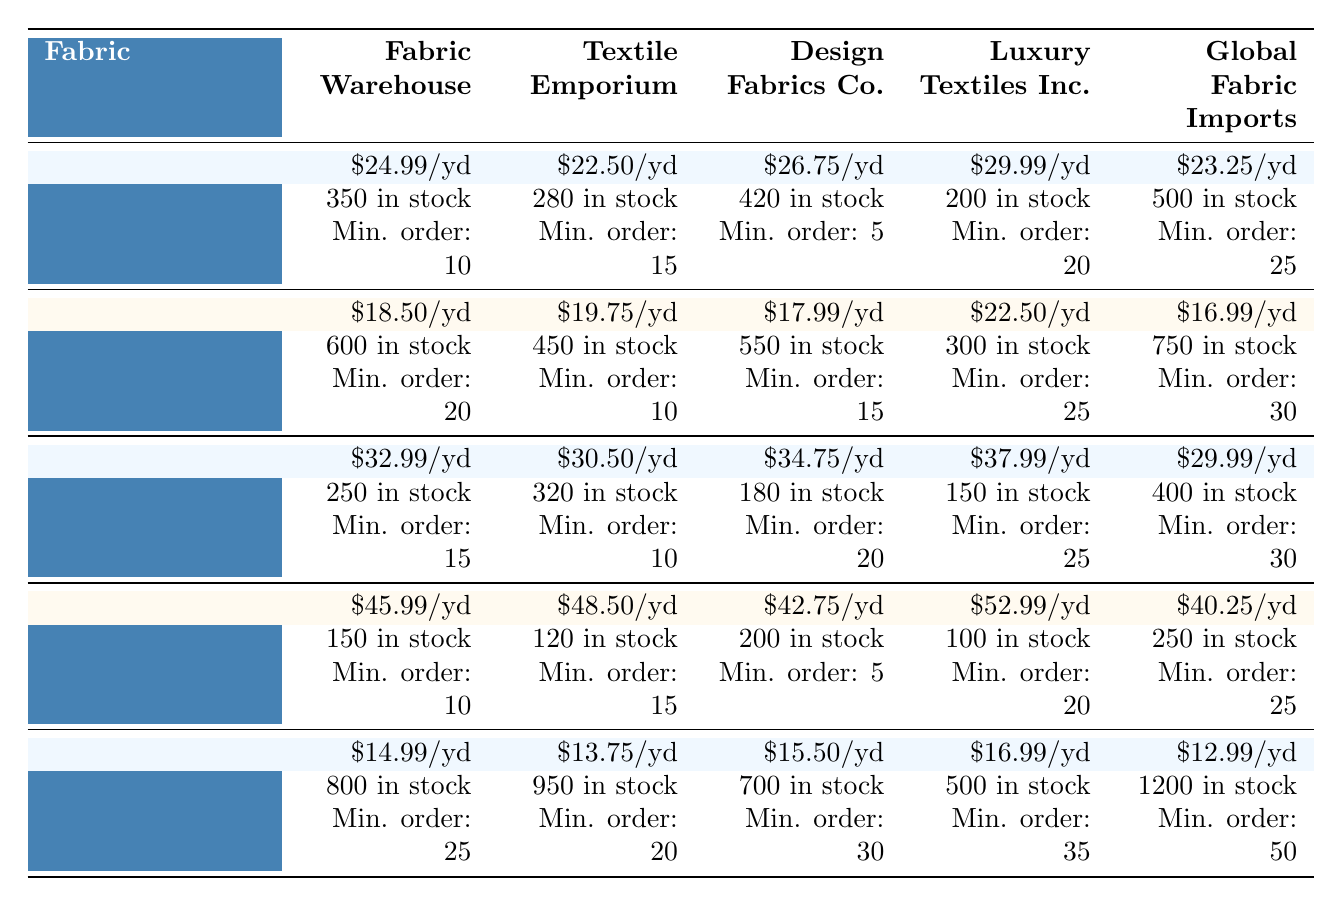What is the price per yard of Velvet from Textile Emporium? The table shows the price per yard of Velvet from Textile Emporium as $22.50.
Answer: $22.50 Which supplier has the highest price for Silk? Looking at the table, Luxury Textiles Inc. has the highest price for Silk at $52.99.
Answer: Luxury Textiles Inc What is the total in-stock quantity of Chenille across all suppliers? The in-stock quantities for Chenille are: Fabric Warehouse - 250, Textile Emporium - 320, Design Fabrics Co. - 180, Luxury Textiles Inc. - 150, and Global Fabric Imports - 400. Adding these amounts gives 250 + 320 + 180 + 150 + 400 = 1300.
Answer: 1300 Which supplier has the lowest minimum order quantity for Linen? The minimum order quantities for Linen are: Fabric Warehouse - 20, Textile Emporium - 10, Design Fabrics Co. - 15, Luxury Textiles Inc. - 25, and Global Fabric Imports - 30. The lowest minimum order quantity is from Textile Emporium at 10 yards.
Answer: 10 Is the stock of Polyester Blend at Global Fabric Imports greater than that of Chenille at Design Fabrics Co.? Polyester Blend at Global Fabric Imports has 1200 in stock, while Chenille at Design Fabrics Co. has 180 in stock. Since 1200 is greater than 180, the answer is yes.
Answer: Yes What is the average price per yard of upholstery fabrics? The upholstery fabrics are Velvet ($24.99), Chenille ($32.99), and Polyester Blend ($14.99). The average is calculated as (24.99 + 32.99 + 14.99) / 3 = 24.32.
Answer: $24.32 Which fabric has the highest stock level and which supplier provides it? From the table, Polyester Blend has the highest stock level at 1200 yards, provided by Global Fabric Imports.
Answer: Polyester Blend, Global Fabric Imports What is the minimum order quantity for Linen from Design Fabrics Co.? The table indicates that the minimum order quantity for Linen from Design Fabrics Co. is 15 yards.
Answer: 15 How does the price per yard of Silk from Global Fabric Imports compare to the lowest priced Silk? The lowest price for Silk is from Design Fabrics Co. at $42.75, while Global Fabric Imports charges $40.25. Since $40.25 is lower, the answer is that Global Fabric Imports has a lower price.
Answer: Lower If I buy 30 yards of Chenille from Textile Emporium, how much will it cost? The price per yard of Chenille from Textile Emporium is $30.50. For 30 yards, the cost is 30 x 30.50 = $915.
Answer: $915 